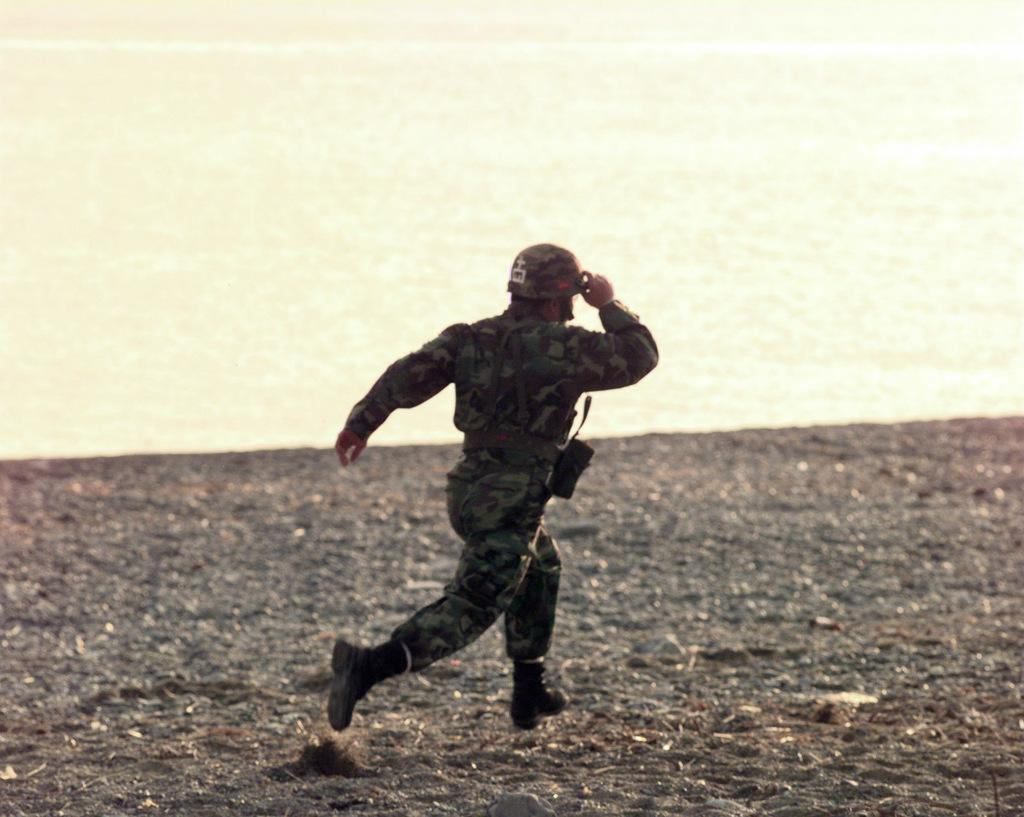Who or what is present in the image? There is a person in the image. What is the person doing in the image? The person is running on the ground. What can be seen in the background of the image? There is water visible in the background of the image. What type of apparel is the person wearing in the image? The provided facts do not mention any specific apparel worn by the person in the image. 